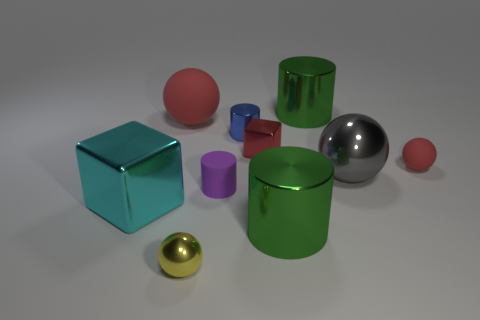Subtract all yellow cylinders. Subtract all red spheres. How many cylinders are left? 4 Subtract all spheres. How many objects are left? 6 Add 9 cyan shiny things. How many cyan shiny things are left? 10 Add 10 big blue metallic objects. How many big blue metallic objects exist? 10 Subtract 0 red cylinders. How many objects are left? 10 Subtract all tiny blue objects. Subtract all large purple shiny blocks. How many objects are left? 9 